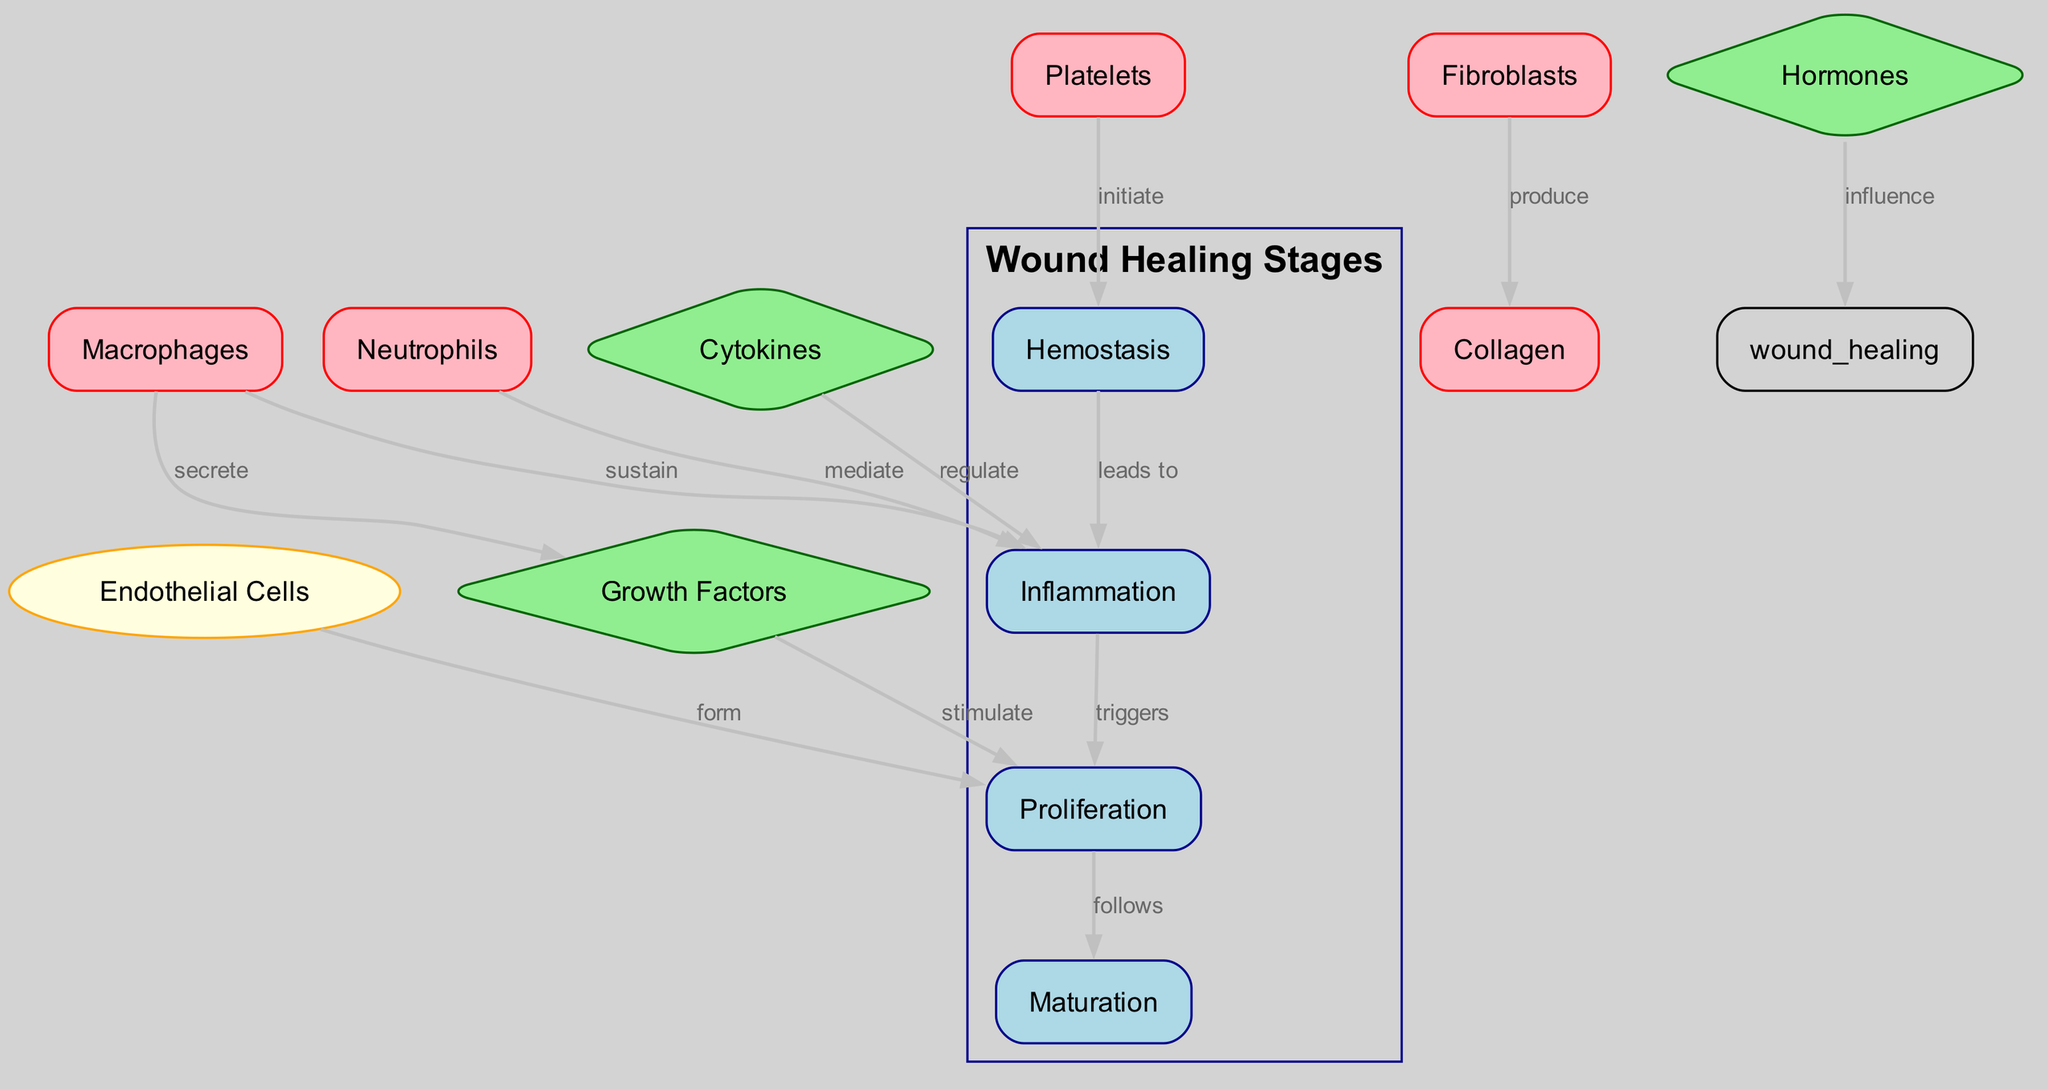What are the four stages of wound healing? The diagram lists the four stages of wound healing as Hemostasis, Inflammation, Proliferation, and Maturation. These are prominently labeled in a grouped section.
Answer: Hemostasis, Inflammation, Proliferation, Maturation How do platelets contribute to wound healing? According to the diagram, platelets initiate the process of hemostasis, which is the first stage of wound healing. Their role is specifically linked to blood clot formation to stop bleeding.
Answer: Initiate What cells are primarily involved in the inflammation stage? The diagram indicates that neutrophils and macrophages are the key cellular components during the inflammation stage, as they are shown mediating and sustaining this phase, respectively.
Answer: Neutrophils, Macrophages Which factors stimulate the proliferation phase? The diagram shows that the proliferation phase is stimulated by growth factors and formed by endothelial cells, linking these components directly to tissue regrowth and new blood vessel formation.
Answer: Growth factors, Endothelial Cells What is the final stage of wound healing? The diagram clearly illustrates that the maturation stage is the last phase in the wound healing process, where collagen remodeling and tissue strengthening occur.
Answer: Maturation How do hormones influence wound healing according to the diagram? The diagram states that hormones influence the overall wound healing process, suggesting they play a crucial regulatory role during the different healing stages, although specific actions are not detailed.
Answer: Influence 